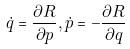Convert formula to latex. <formula><loc_0><loc_0><loc_500><loc_500>\dot { q } = \frac { \partial R } { \partial p } , \dot { p } = - \frac { \partial R } { \partial q }</formula> 